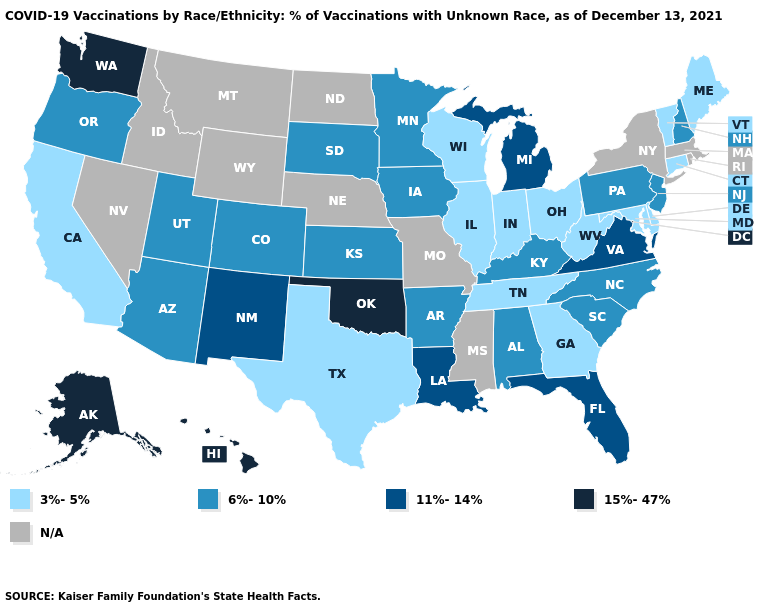Does the first symbol in the legend represent the smallest category?
Keep it brief. Yes. What is the lowest value in the USA?
Keep it brief. 3%-5%. Name the states that have a value in the range 15%-47%?
Give a very brief answer. Alaska, Hawaii, Oklahoma, Washington. What is the lowest value in states that border Montana?
Write a very short answer. 6%-10%. What is the lowest value in states that border South Carolina?
Keep it brief. 3%-5%. What is the highest value in the South ?
Give a very brief answer. 15%-47%. What is the value of South Dakota?
Keep it brief. 6%-10%. How many symbols are there in the legend?
Keep it brief. 5. Which states hav the highest value in the MidWest?
Be succinct. Michigan. What is the value of South Carolina?
Be succinct. 6%-10%. Among the states that border Minnesota , does Wisconsin have the highest value?
Answer briefly. No. What is the lowest value in the South?
Answer briefly. 3%-5%. What is the highest value in the South ?
Give a very brief answer. 15%-47%. What is the value of Rhode Island?
Concise answer only. N/A. 